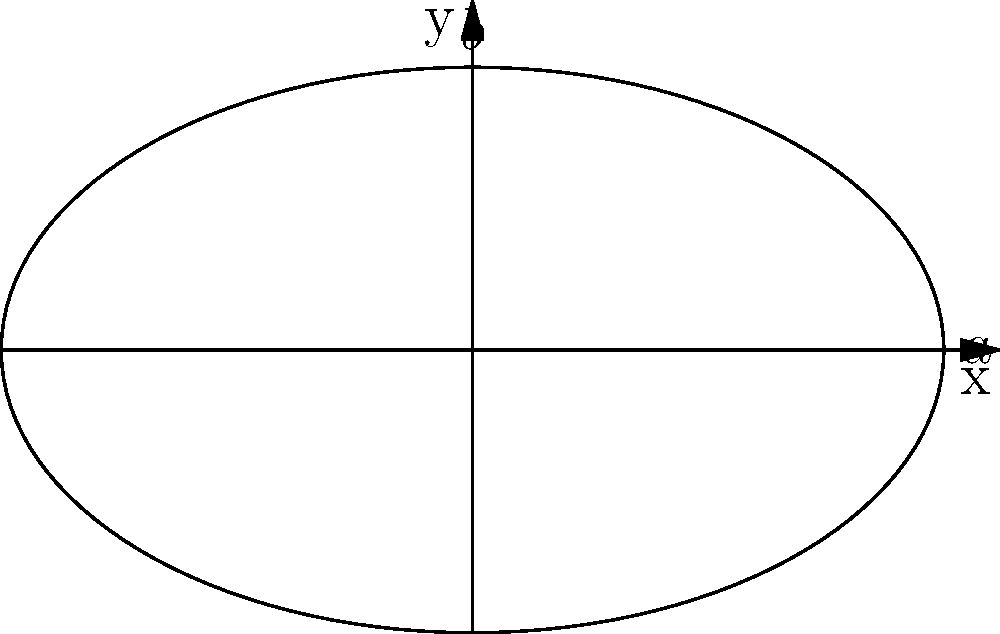An elliptical stage has semi-major axis $a=5$ meters and semi-minor axis $b=3$ meters. Using polar coordinates, calculate the area of this stage. Express your answer in square meters, rounded to two decimal places. To calculate the area of an elliptical stage using polar coordinates, we'll follow these steps:

1) The general equation of an ellipse in polar coordinates is:
   $$r(\theta) = \frac{ab}{\sqrt{(b\cos\theta)^2 + (a\sin\theta)^2}}$$

2) The area of a region in polar coordinates is given by:
   $$A = \frac{1}{2}\int_0^{2\pi} r(\theta)^2 d\theta$$

3) Substituting our ellipse equation:
   $$A = \frac{1}{2}\int_0^{2\pi} \frac{a^2b^2}{(b\cos\theta)^2 + (a\sin\theta)^2} d\theta$$

4) This integral can be evaluated to:
   $$A = \frac{1}{2}ab\int_0^{2\pi} d\theta = \pi ab$$

5) Now, let's substitute our values:
   $$A = \pi \cdot 5 \cdot 3 = 15\pi$$

6) Calculate and round to two decimal places:
   $$A \approx 47.12 \text{ m}^2$$

Thus, the area of the elliptical stage is approximately 47.12 square meters.
Answer: $47.12 \text{ m}^2$ 